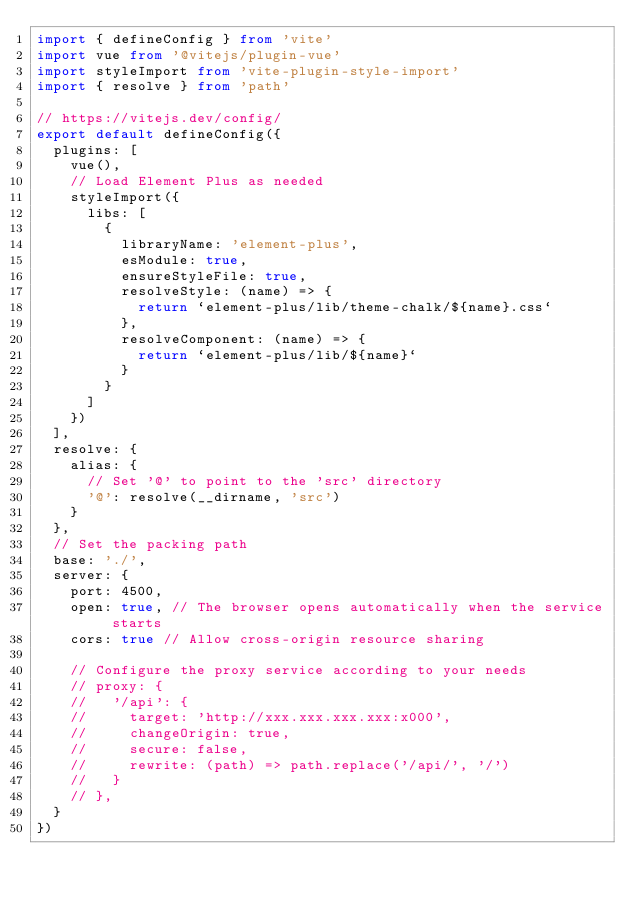Convert code to text. <code><loc_0><loc_0><loc_500><loc_500><_TypeScript_>import { defineConfig } from 'vite'
import vue from '@vitejs/plugin-vue'
import styleImport from 'vite-plugin-style-import'
import { resolve } from 'path'

// https://vitejs.dev/config/
export default defineConfig({
  plugins: [
    vue(),
    // Load Element Plus as needed
    styleImport({
      libs: [
        {
          libraryName: 'element-plus',
          esModule: true,
          ensureStyleFile: true,
          resolveStyle: (name) => {
            return `element-plus/lib/theme-chalk/${name}.css`
          },
          resolveComponent: (name) => {
            return `element-plus/lib/${name}`
          }
        }
      ]
    })
  ],
  resolve: {
    alias: {
      // Set '@' to point to the 'src' directory
      '@': resolve(__dirname, 'src')
    }
  },
  // Set the packing path
  base: './',
  server: {
    port: 4500,
    open: true, // The browser opens automatically when the service starts
    cors: true // Allow cross-origin resource sharing

    // Configure the proxy service according to your needs
    // proxy: {
    //   '/api': {
    //     target: 'http://xxx.xxx.xxx.xxx:x000',
    //     changeOrigin: true,
    //     secure: false,
    //     rewrite: (path) => path.replace('/api/', '/')
    //   }
    // },
  }
})
</code> 